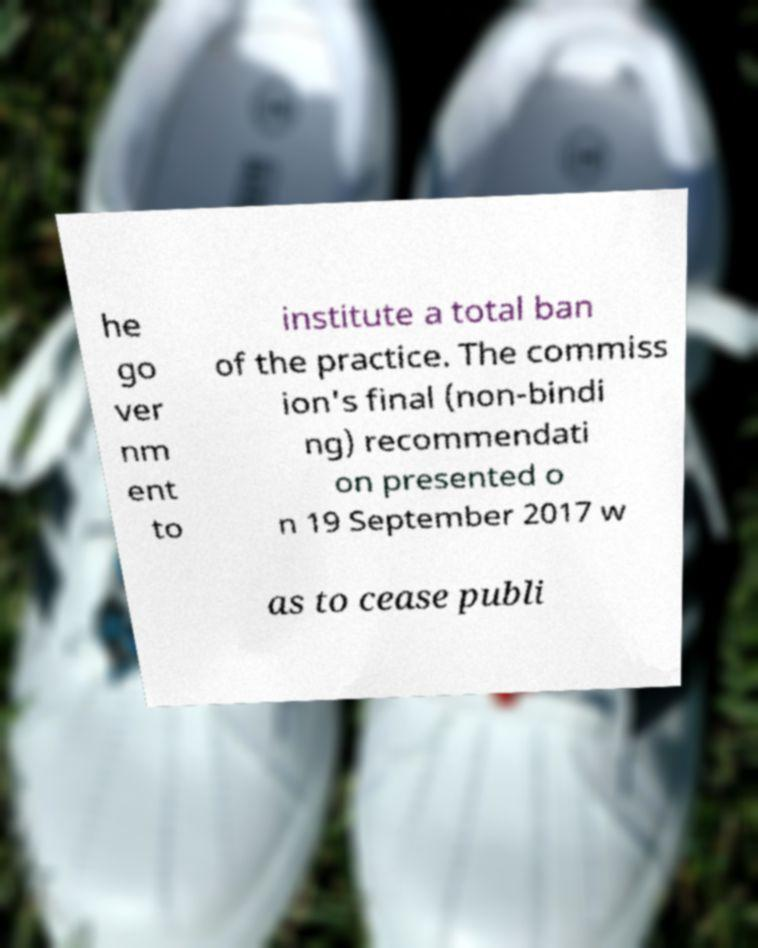Can you accurately transcribe the text from the provided image for me? he go ver nm ent to institute a total ban of the practice. The commiss ion's final (non-bindi ng) recommendati on presented o n 19 September 2017 w as to cease publi 